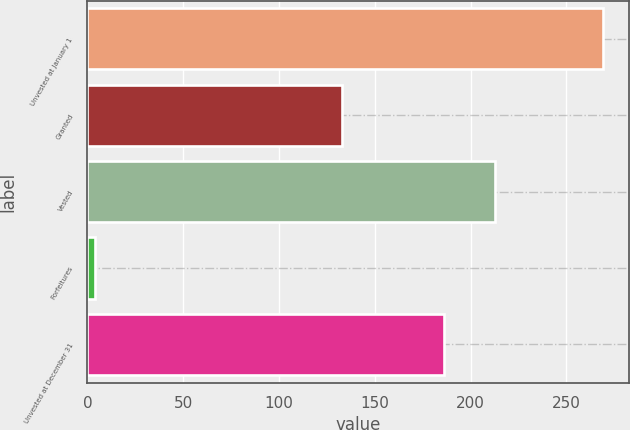Convert chart. <chart><loc_0><loc_0><loc_500><loc_500><bar_chart><fcel>Unvested at January 1<fcel>Granted<fcel>Vested<fcel>Forfeitures<fcel>Unvested at December 31<nl><fcel>269<fcel>133<fcel>212.5<fcel>4<fcel>186<nl></chart> 